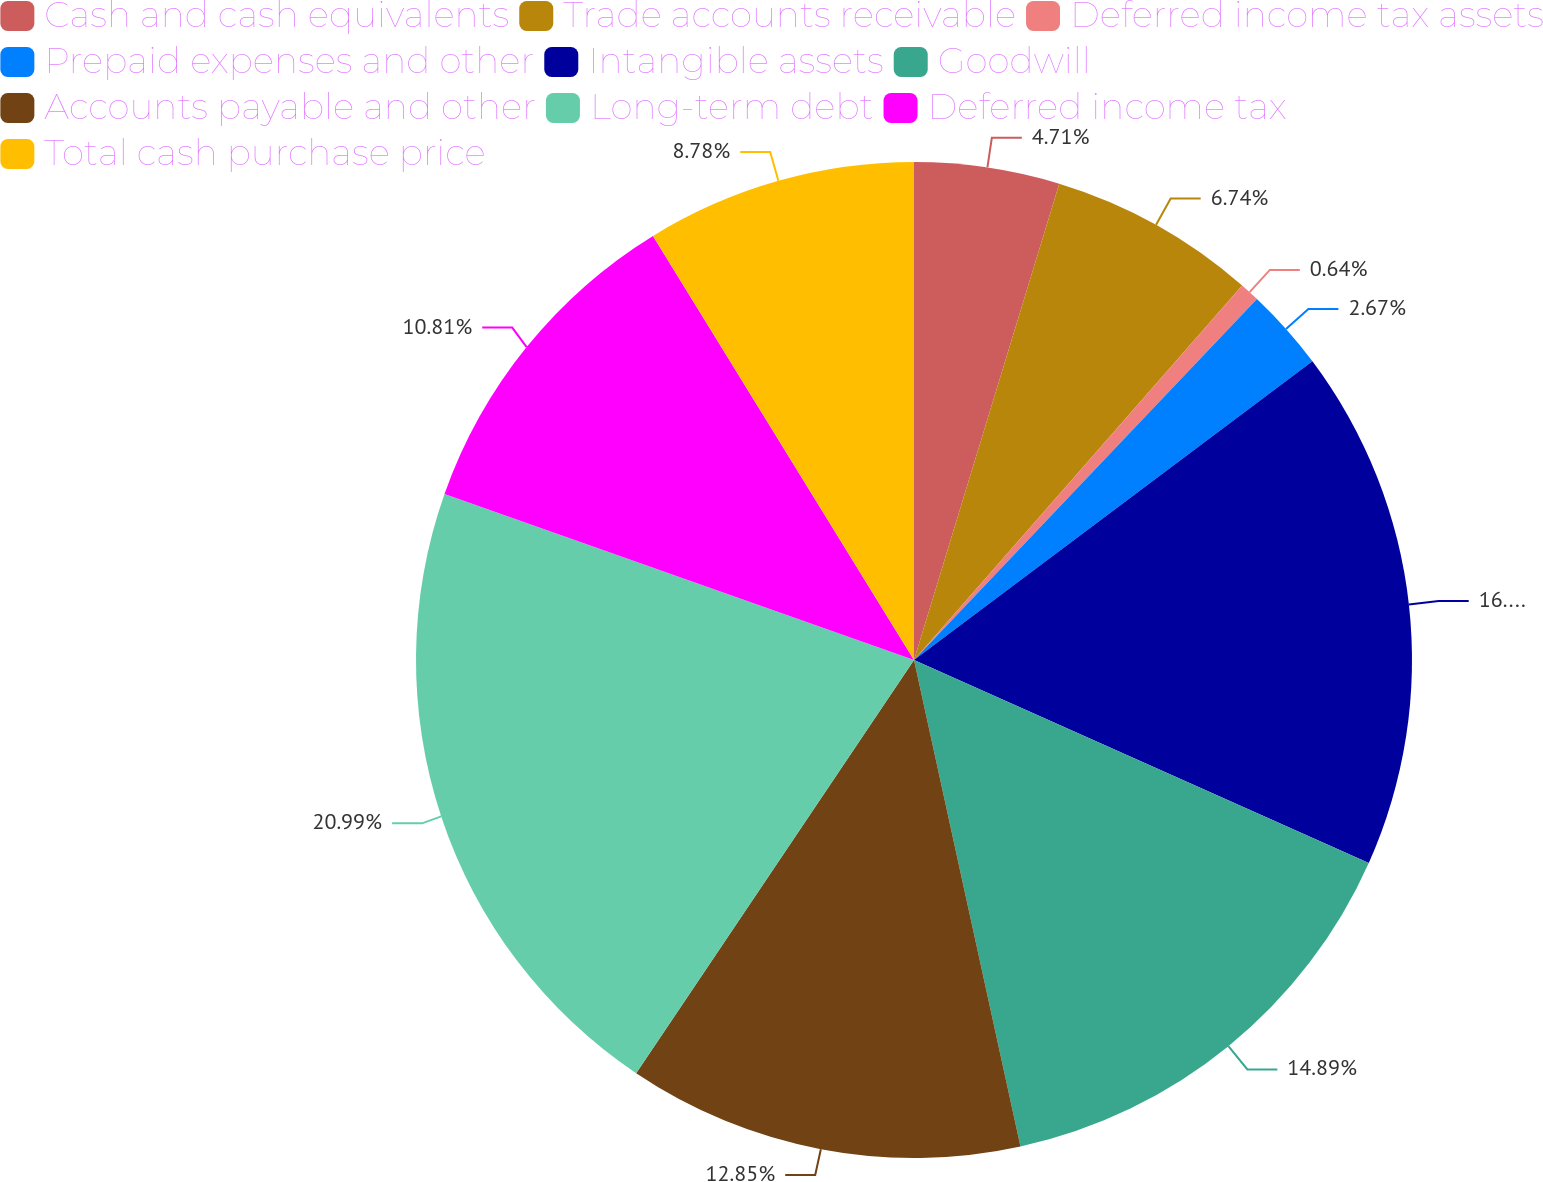Convert chart. <chart><loc_0><loc_0><loc_500><loc_500><pie_chart><fcel>Cash and cash equivalents<fcel>Trade accounts receivable<fcel>Deferred income tax assets<fcel>Prepaid expenses and other<fcel>Intangible assets<fcel>Goodwill<fcel>Accounts payable and other<fcel>Long-term debt<fcel>Deferred income tax<fcel>Total cash purchase price<nl><fcel>4.71%<fcel>6.74%<fcel>0.64%<fcel>2.67%<fcel>16.92%<fcel>14.89%<fcel>12.85%<fcel>20.99%<fcel>10.81%<fcel>8.78%<nl></chart> 